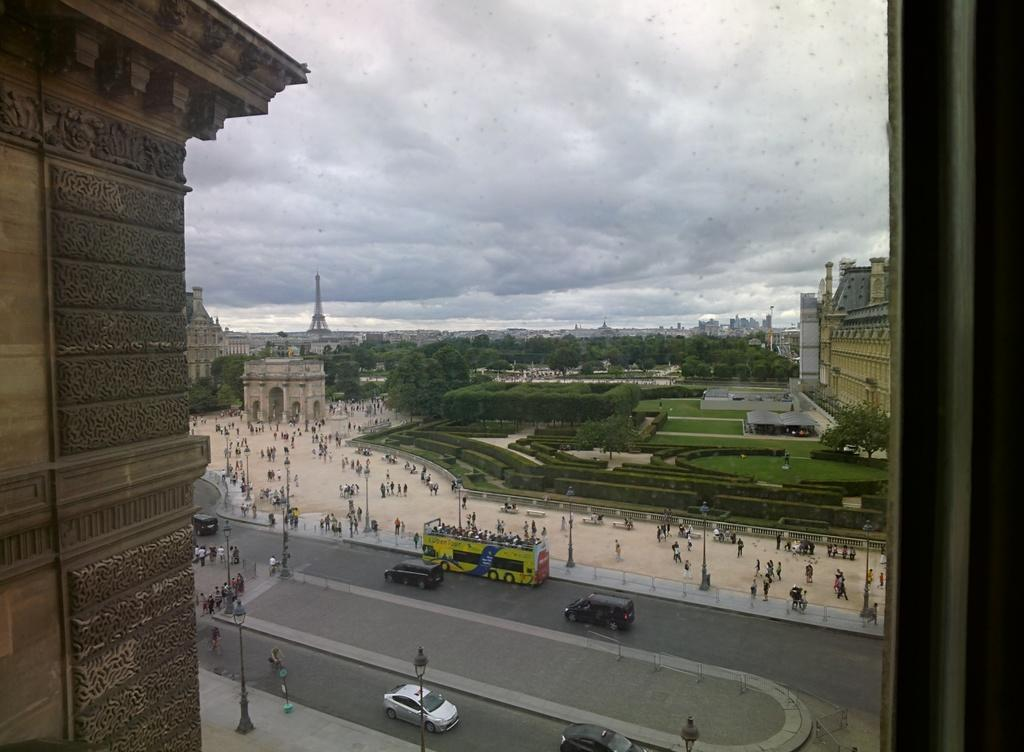What can be seen moving on the road in the image? There are vehicles on the road in the image. What are the people in the image doing? There are people walking in the image. What type of natural elements can be seen in the image? There are trees in the image. What type of man-made structures can be seen in the image? There are light-poles, buildings, a fort, and a tower in the image. How is the sky depicted in the image? The sky is in white and blue color in the image. Can you tell me how many grapes are hanging from the trees in the image? There are no grapes visible in the image; only trees are present. What type of bat is flying near the tower in the image? There are no bats present in the image; only vehicles, people, trees, light-poles, buildings, a fort, and a tower are visible. How many ducks are swimming in the water near the fort in the image? There is no water or ducks present in the image; only vehicles, people, trees, light-poles, buildings, a fort, and a tower are visible. 